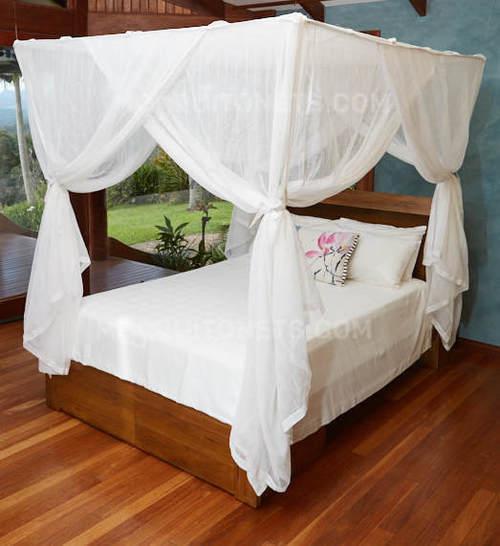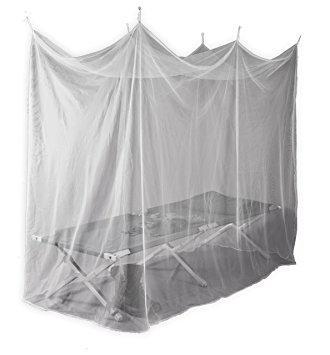The first image is the image on the left, the second image is the image on the right. Assess this claim about the two images: "One image on a white background shows a simple protective bed net that gathers to a point.". Correct or not? Answer yes or no. No. 